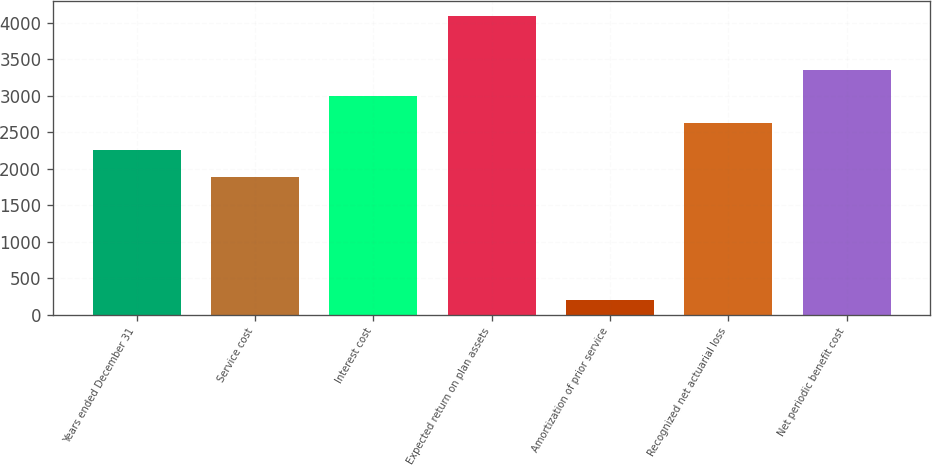Convert chart. <chart><loc_0><loc_0><loc_500><loc_500><bar_chart><fcel>Years ended December 31<fcel>Service cost<fcel>Interest cost<fcel>Expected return on plan assets<fcel>Amortization of prior service<fcel>Recognized net actuarial loss<fcel>Net periodic benefit cost<nl><fcel>2253.8<fcel>1886<fcel>2989.4<fcel>4092.8<fcel>196<fcel>2621.6<fcel>3357.2<nl></chart> 